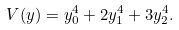<formula> <loc_0><loc_0><loc_500><loc_500>V ( y ) = y _ { 0 } ^ { 4 } + 2 y _ { 1 } ^ { 4 } + 3 y _ { 2 } ^ { 4 } .</formula> 